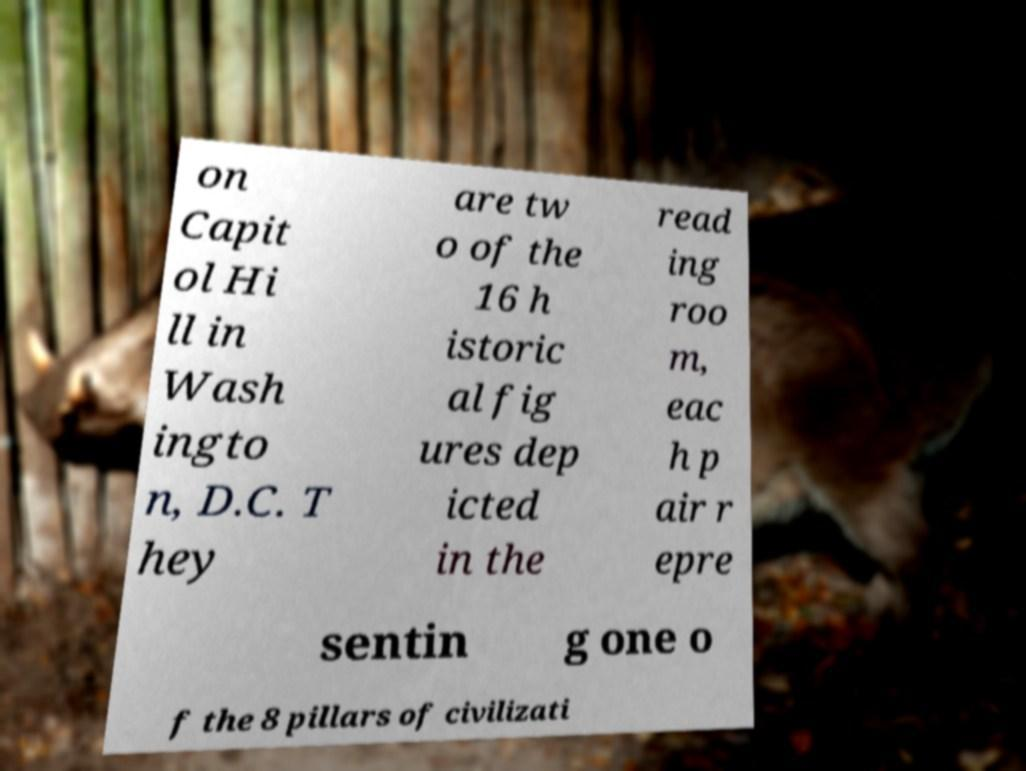Could you extract and type out the text from this image? on Capit ol Hi ll in Wash ingto n, D.C. T hey are tw o of the 16 h istoric al fig ures dep icted in the read ing roo m, eac h p air r epre sentin g one o f the 8 pillars of civilizati 